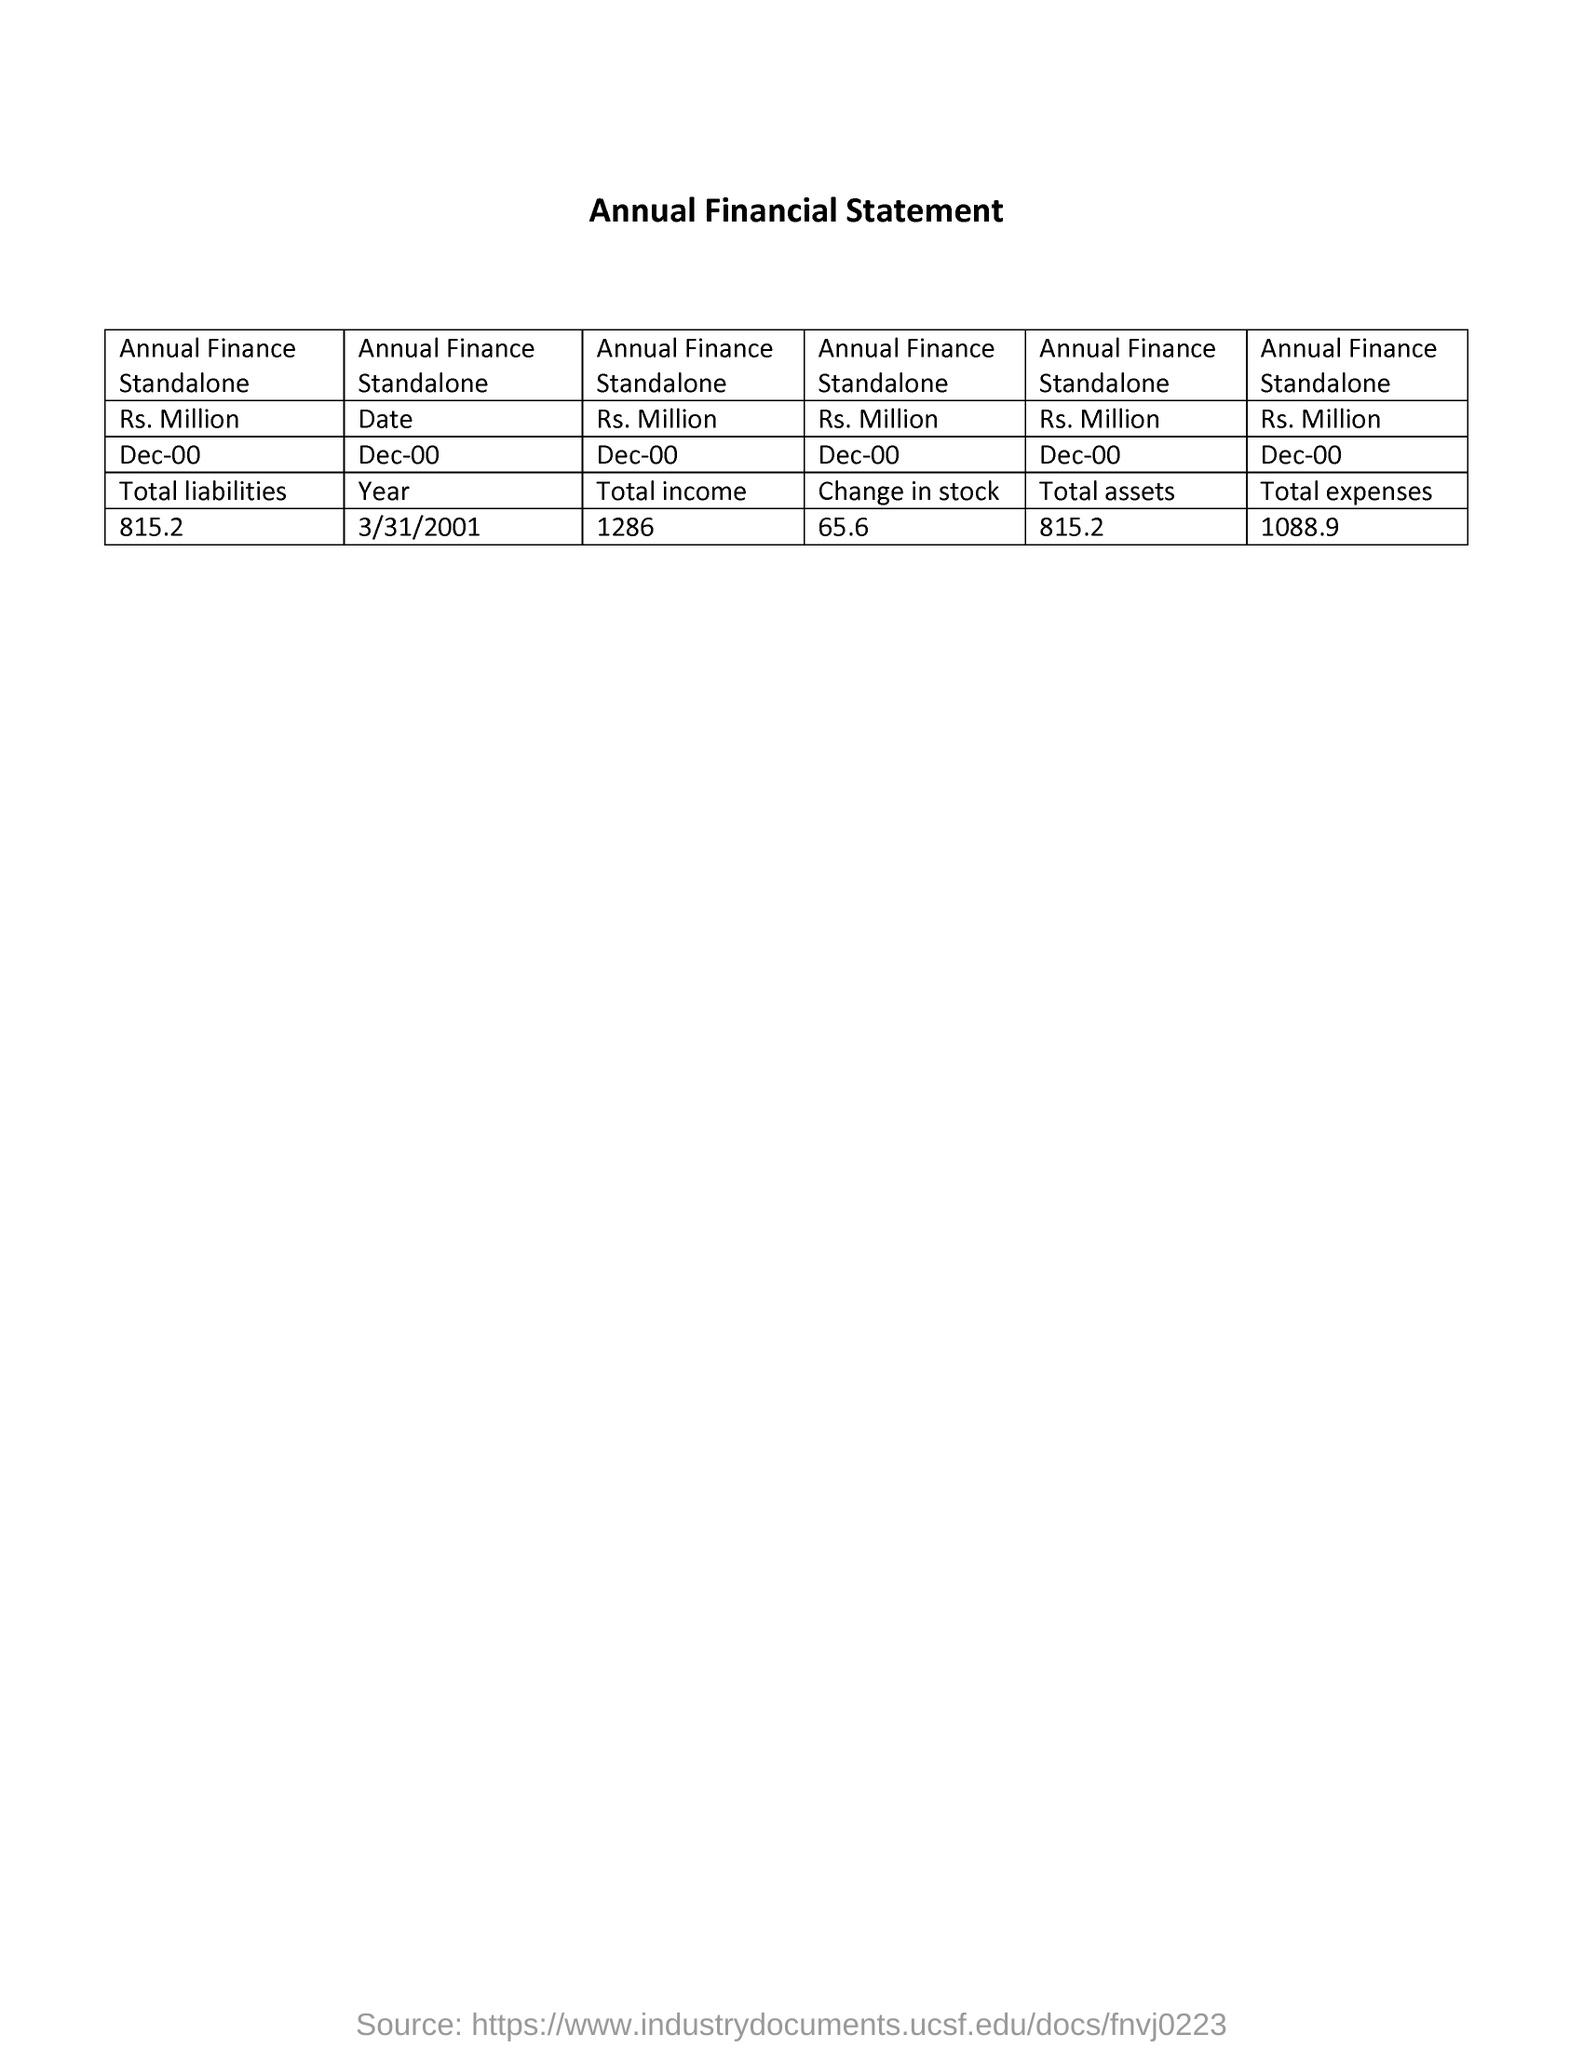What is the heading of the table?
Make the answer very short. Annual Financial Statement. How is monetaory value mentioned?
Keep it short and to the point. Rs. Million. What  value is given under "Total liabilities"?
Ensure brevity in your answer.  815.2. What is the "Date" mentioned in the Annual Financial Statement?
Give a very brief answer. 3/31/2001. Mention the value of "Total income" of Standalone?
Provide a succinct answer. 1286. What is th value of "Change in stock"?
Ensure brevity in your answer.  65.6. Mention the value of "Total assets" of Annual Finance Standalone?
Make the answer very short. 815.2. What  value is given under "Total expenses"?
Give a very brief answer. 1088.9. 